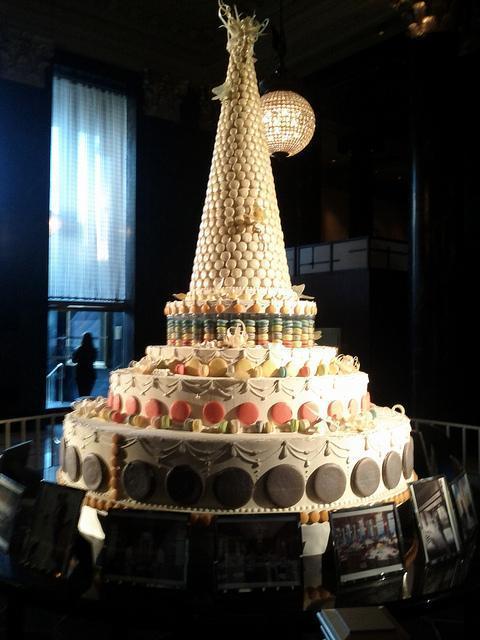Does the image validate the caption "The person is close to the cake."?
Answer yes or no. No. 